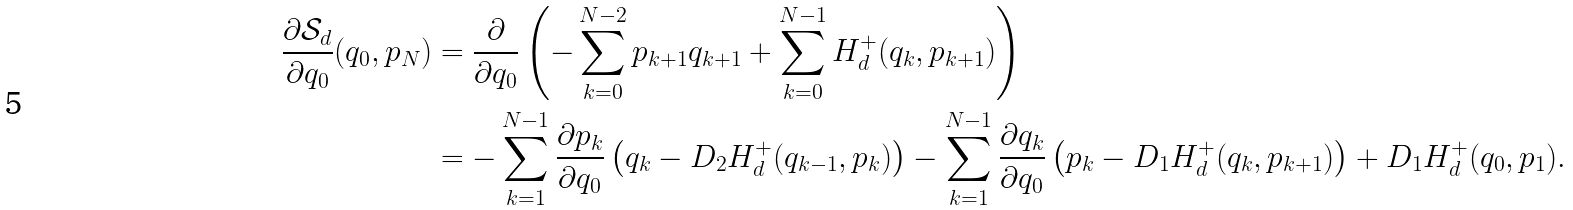Convert formula to latex. <formula><loc_0><loc_0><loc_500><loc_500>\frac { \partial \mathcal { S } _ { d } } { \partial q _ { 0 } } ( q _ { 0 } , p _ { N } ) & = \frac { \partial } { \partial q _ { 0 } } \left ( - \sum _ { k = 0 } ^ { N - 2 } p _ { k + 1 } q _ { k + 1 } + \sum _ { k = 0 } ^ { N - 1 } H _ { d } ^ { + } ( q _ { k } , p _ { k + 1 } ) \right ) \\ & = - \sum _ { k = 1 } ^ { N - 1 } \frac { \partial p _ { k } } { \partial q _ { 0 } } \left ( q _ { k } - D _ { 2 } H _ { d } ^ { + } ( q _ { k - 1 } , p _ { k } ) \right ) - \sum _ { k = 1 } ^ { N - 1 } \frac { \partial q _ { k } } { \partial q _ { 0 } } \left ( p _ { k } - D _ { 1 } H _ { d } ^ { + } ( q _ { k } , p _ { k + 1 } ) \right ) + D _ { 1 } H _ { d } ^ { + } ( q _ { 0 } , p _ { 1 } ) .</formula> 